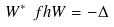Convert formula to latex. <formula><loc_0><loc_0><loc_500><loc_500>W ^ { * } \ f h W = - \Delta</formula> 